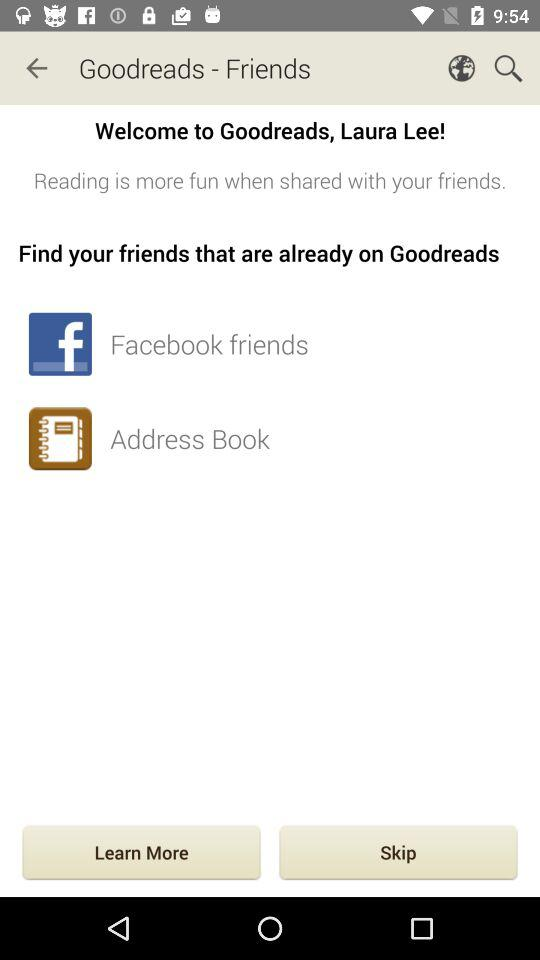What is the user name? The user name is Laura Lee. 